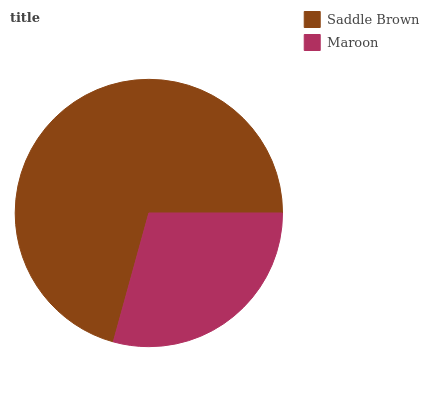Is Maroon the minimum?
Answer yes or no. Yes. Is Saddle Brown the maximum?
Answer yes or no. Yes. Is Maroon the maximum?
Answer yes or no. No. Is Saddle Brown greater than Maroon?
Answer yes or no. Yes. Is Maroon less than Saddle Brown?
Answer yes or no. Yes. Is Maroon greater than Saddle Brown?
Answer yes or no. No. Is Saddle Brown less than Maroon?
Answer yes or no. No. Is Saddle Brown the high median?
Answer yes or no. Yes. Is Maroon the low median?
Answer yes or no. Yes. Is Maroon the high median?
Answer yes or no. No. Is Saddle Brown the low median?
Answer yes or no. No. 